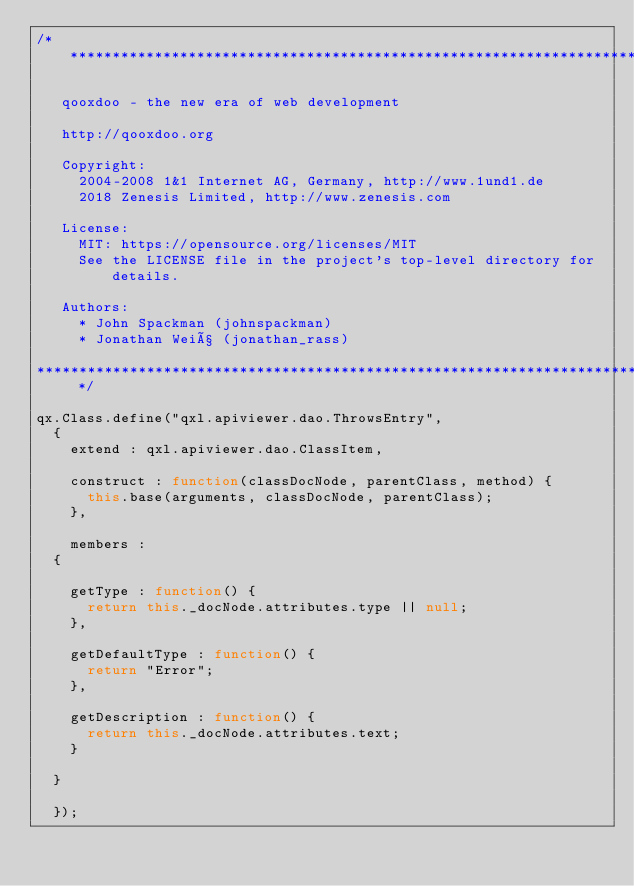<code> <loc_0><loc_0><loc_500><loc_500><_JavaScript_>/* ************************************************************************

   qooxdoo - the new era of web development

   http://qooxdoo.org

   Copyright:
     2004-2008 1&1 Internet AG, Germany, http://www.1und1.de
     2018 Zenesis Limited, http://www.zenesis.com

   License:
     MIT: https://opensource.org/licenses/MIT
     See the LICENSE file in the project's top-level directory for details.

   Authors:
     * John Spackman (johnspackman)
     * Jonathan Weiß (jonathan_rass)

************************************************************************ */

qx.Class.define("qxl.apiviewer.dao.ThrowsEntry",
  {
    extend : qxl.apiviewer.dao.ClassItem,

    construct : function(classDocNode, parentClass, method) {
      this.base(arguments, classDocNode, parentClass);
    },

    members :
  {

    getType : function() {
      return this._docNode.attributes.type || null;
    },

    getDefaultType : function() {
      return "Error";
    },

    getDescription : function() {
      return this._docNode.attributes.text;
    }

  }

  });
</code> 